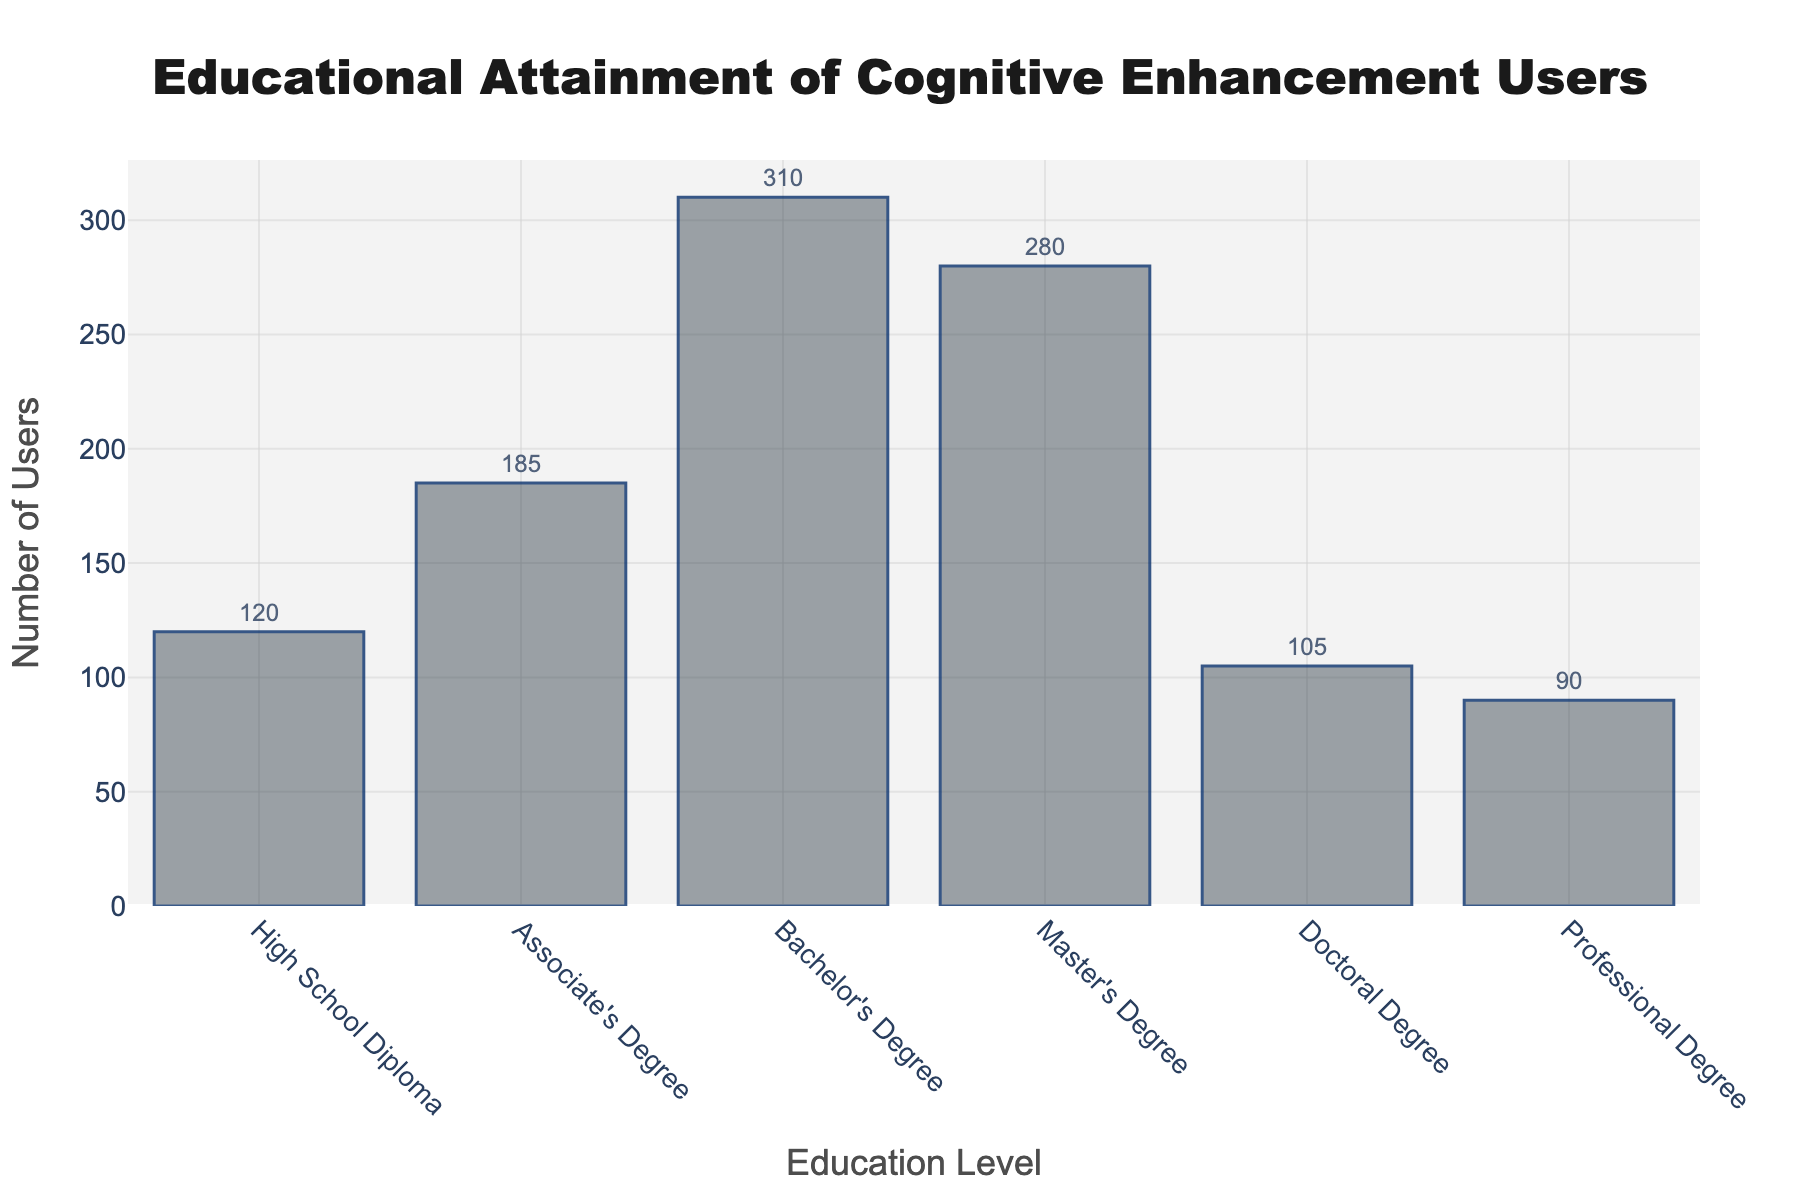What is the title of the figure? The title of the figure is located at the top and is specified in the layout of the histogram. It reads "Educational Attainment of Cognitive Enhancement Users."
Answer: Educational Attainment of Cognitive Enhancement Users What does the x-axis represent? The x-axis represents different levels of education reported by the individuals using cognitive enhancement methods.
Answer: Education Levels How many data points are represented in the figure? The figure has six bars, each corresponding to a different education level (High School Diploma, Associate's Degree, Bachelor's Degree, Master's Degree, Doctoral Degree, and Professional Degree). Therefore, there are six data points.
Answer: 6 Which education level has the highest number of users? By observing the height of the bars, the Bachelor's Degree level has the tallest bar, indicating that it has the highest number of users.
Answer: Bachelor's Degree What is the sum of users with Master's Degrees and Doctoral Degrees? The number of users with Master's Degrees is 280 and with Doctoral Degrees is 105. Adding these together: 280 + 105 = 385.
Answer: 385 Which education level has fewer users, High School Diploma or Professional Degree? By comparing the heights of the bars for High School Diploma and Professional Degree, it is clear that Professional Degree has fewer users (90) than High School Diploma (120).
Answer: Professional Degree What is the difference in the number of users between Bachelor's Degrees and Associate's Degrees? The number of users with Bachelor's Degrees is 310, and with Associate's Degrees is 185. Subtracting these: 310 - 185 = 125.
Answer: 125 What is the average number of users across all education levels? To find the average, sum all the users and divide by the number of education levels: (120 + 185 + 310 + 280 + 105 + 90) / 6 = 1090 / 6 = approximately 181.67.
Answer: approximately 181.67 How do the numbers of users with a Bachelor's Degree compare to those with a Master's Degree? By observing the bars, it can be seen that the number of users with a Bachelor's Degree is 310, which is higher than the number of users with a Master's Degree (280).
Answer: Bachelor's Degree has more users Which education levels have more than 200 users? By examining the heights of the bars, the education levels with more than 200 users are Associate's Degree (185), Bachelor's Degree (310), and Master's Degree (280).
Answer: Bachelor's Degree and Master's Degree 